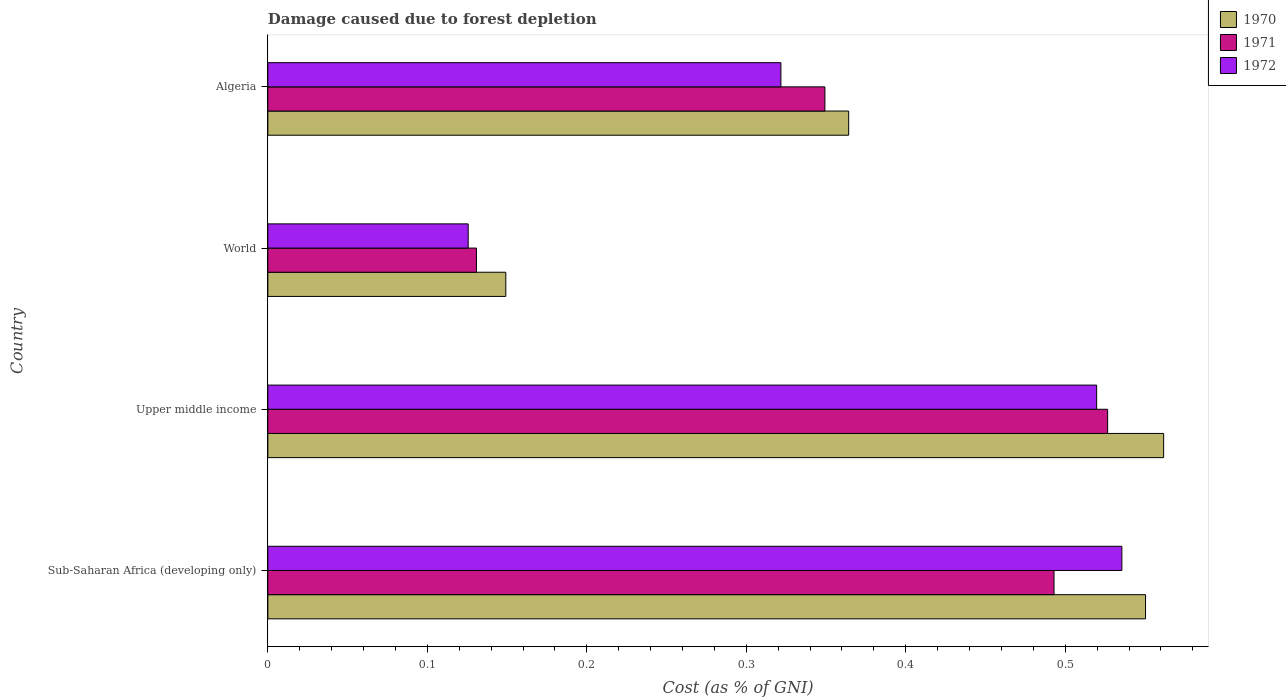How many different coloured bars are there?
Make the answer very short. 3. How many groups of bars are there?
Keep it short and to the point. 4. Are the number of bars per tick equal to the number of legend labels?
Make the answer very short. Yes. What is the label of the 4th group of bars from the top?
Offer a very short reply. Sub-Saharan Africa (developing only). In how many cases, is the number of bars for a given country not equal to the number of legend labels?
Provide a succinct answer. 0. What is the cost of damage caused due to forest depletion in 1971 in Upper middle income?
Keep it short and to the point. 0.53. Across all countries, what is the maximum cost of damage caused due to forest depletion in 1971?
Your answer should be very brief. 0.53. Across all countries, what is the minimum cost of damage caused due to forest depletion in 1970?
Ensure brevity in your answer.  0.15. In which country was the cost of damage caused due to forest depletion in 1970 maximum?
Keep it short and to the point. Upper middle income. In which country was the cost of damage caused due to forest depletion in 1972 minimum?
Your response must be concise. World. What is the total cost of damage caused due to forest depletion in 1970 in the graph?
Ensure brevity in your answer.  1.63. What is the difference between the cost of damage caused due to forest depletion in 1972 in Sub-Saharan Africa (developing only) and that in Upper middle income?
Provide a short and direct response. 0.02. What is the difference between the cost of damage caused due to forest depletion in 1970 in Sub-Saharan Africa (developing only) and the cost of damage caused due to forest depletion in 1971 in World?
Provide a succinct answer. 0.42. What is the average cost of damage caused due to forest depletion in 1972 per country?
Provide a succinct answer. 0.38. What is the difference between the cost of damage caused due to forest depletion in 1972 and cost of damage caused due to forest depletion in 1970 in Sub-Saharan Africa (developing only)?
Give a very brief answer. -0.01. What is the ratio of the cost of damage caused due to forest depletion in 1971 in Sub-Saharan Africa (developing only) to that in World?
Ensure brevity in your answer.  3.77. Is the difference between the cost of damage caused due to forest depletion in 1972 in Sub-Saharan Africa (developing only) and World greater than the difference between the cost of damage caused due to forest depletion in 1970 in Sub-Saharan Africa (developing only) and World?
Offer a very short reply. Yes. What is the difference between the highest and the second highest cost of damage caused due to forest depletion in 1972?
Give a very brief answer. 0.02. What is the difference between the highest and the lowest cost of damage caused due to forest depletion in 1971?
Your response must be concise. 0.4. In how many countries, is the cost of damage caused due to forest depletion in 1970 greater than the average cost of damage caused due to forest depletion in 1970 taken over all countries?
Make the answer very short. 2. Is the sum of the cost of damage caused due to forest depletion in 1971 in Upper middle income and World greater than the maximum cost of damage caused due to forest depletion in 1970 across all countries?
Offer a very short reply. Yes. What does the 2nd bar from the top in Upper middle income represents?
Make the answer very short. 1971. How many bars are there?
Provide a succinct answer. 12. What is the difference between two consecutive major ticks on the X-axis?
Provide a short and direct response. 0.1. Does the graph contain any zero values?
Offer a very short reply. No. Does the graph contain grids?
Keep it short and to the point. No. Where does the legend appear in the graph?
Your answer should be very brief. Top right. How many legend labels are there?
Your response must be concise. 3. What is the title of the graph?
Offer a terse response. Damage caused due to forest depletion. What is the label or title of the X-axis?
Give a very brief answer. Cost (as % of GNI). What is the Cost (as % of GNI) of 1970 in Sub-Saharan Africa (developing only)?
Offer a terse response. 0.55. What is the Cost (as % of GNI) of 1971 in Sub-Saharan Africa (developing only)?
Your answer should be very brief. 0.49. What is the Cost (as % of GNI) of 1972 in Sub-Saharan Africa (developing only)?
Your answer should be compact. 0.54. What is the Cost (as % of GNI) in 1970 in Upper middle income?
Give a very brief answer. 0.56. What is the Cost (as % of GNI) of 1971 in Upper middle income?
Your answer should be very brief. 0.53. What is the Cost (as % of GNI) in 1972 in Upper middle income?
Offer a very short reply. 0.52. What is the Cost (as % of GNI) of 1970 in World?
Your answer should be compact. 0.15. What is the Cost (as % of GNI) in 1971 in World?
Give a very brief answer. 0.13. What is the Cost (as % of GNI) in 1972 in World?
Provide a short and direct response. 0.13. What is the Cost (as % of GNI) in 1970 in Algeria?
Your response must be concise. 0.36. What is the Cost (as % of GNI) of 1971 in Algeria?
Your answer should be compact. 0.35. What is the Cost (as % of GNI) in 1972 in Algeria?
Ensure brevity in your answer.  0.32. Across all countries, what is the maximum Cost (as % of GNI) in 1970?
Ensure brevity in your answer.  0.56. Across all countries, what is the maximum Cost (as % of GNI) of 1971?
Your answer should be very brief. 0.53. Across all countries, what is the maximum Cost (as % of GNI) of 1972?
Give a very brief answer. 0.54. Across all countries, what is the minimum Cost (as % of GNI) in 1970?
Your answer should be compact. 0.15. Across all countries, what is the minimum Cost (as % of GNI) in 1971?
Provide a short and direct response. 0.13. Across all countries, what is the minimum Cost (as % of GNI) in 1972?
Your response must be concise. 0.13. What is the total Cost (as % of GNI) in 1970 in the graph?
Make the answer very short. 1.63. What is the total Cost (as % of GNI) in 1971 in the graph?
Provide a succinct answer. 1.5. What is the total Cost (as % of GNI) of 1972 in the graph?
Your answer should be very brief. 1.5. What is the difference between the Cost (as % of GNI) in 1970 in Sub-Saharan Africa (developing only) and that in Upper middle income?
Give a very brief answer. -0.01. What is the difference between the Cost (as % of GNI) in 1971 in Sub-Saharan Africa (developing only) and that in Upper middle income?
Offer a terse response. -0.03. What is the difference between the Cost (as % of GNI) in 1972 in Sub-Saharan Africa (developing only) and that in Upper middle income?
Provide a succinct answer. 0.02. What is the difference between the Cost (as % of GNI) in 1970 in Sub-Saharan Africa (developing only) and that in World?
Offer a very short reply. 0.4. What is the difference between the Cost (as % of GNI) in 1971 in Sub-Saharan Africa (developing only) and that in World?
Your answer should be compact. 0.36. What is the difference between the Cost (as % of GNI) of 1972 in Sub-Saharan Africa (developing only) and that in World?
Give a very brief answer. 0.41. What is the difference between the Cost (as % of GNI) of 1970 in Sub-Saharan Africa (developing only) and that in Algeria?
Keep it short and to the point. 0.19. What is the difference between the Cost (as % of GNI) in 1971 in Sub-Saharan Africa (developing only) and that in Algeria?
Provide a succinct answer. 0.14. What is the difference between the Cost (as % of GNI) in 1972 in Sub-Saharan Africa (developing only) and that in Algeria?
Give a very brief answer. 0.21. What is the difference between the Cost (as % of GNI) of 1970 in Upper middle income and that in World?
Make the answer very short. 0.41. What is the difference between the Cost (as % of GNI) in 1971 in Upper middle income and that in World?
Provide a short and direct response. 0.4. What is the difference between the Cost (as % of GNI) in 1972 in Upper middle income and that in World?
Your answer should be compact. 0.39. What is the difference between the Cost (as % of GNI) of 1970 in Upper middle income and that in Algeria?
Your answer should be very brief. 0.2. What is the difference between the Cost (as % of GNI) of 1971 in Upper middle income and that in Algeria?
Provide a succinct answer. 0.18. What is the difference between the Cost (as % of GNI) of 1972 in Upper middle income and that in Algeria?
Your answer should be very brief. 0.2. What is the difference between the Cost (as % of GNI) of 1970 in World and that in Algeria?
Keep it short and to the point. -0.21. What is the difference between the Cost (as % of GNI) in 1971 in World and that in Algeria?
Your answer should be compact. -0.22. What is the difference between the Cost (as % of GNI) of 1972 in World and that in Algeria?
Your answer should be very brief. -0.2. What is the difference between the Cost (as % of GNI) of 1970 in Sub-Saharan Africa (developing only) and the Cost (as % of GNI) of 1971 in Upper middle income?
Give a very brief answer. 0.02. What is the difference between the Cost (as % of GNI) in 1970 in Sub-Saharan Africa (developing only) and the Cost (as % of GNI) in 1972 in Upper middle income?
Give a very brief answer. 0.03. What is the difference between the Cost (as % of GNI) in 1971 in Sub-Saharan Africa (developing only) and the Cost (as % of GNI) in 1972 in Upper middle income?
Make the answer very short. -0.03. What is the difference between the Cost (as % of GNI) in 1970 in Sub-Saharan Africa (developing only) and the Cost (as % of GNI) in 1971 in World?
Make the answer very short. 0.42. What is the difference between the Cost (as % of GNI) in 1970 in Sub-Saharan Africa (developing only) and the Cost (as % of GNI) in 1972 in World?
Make the answer very short. 0.42. What is the difference between the Cost (as % of GNI) of 1971 in Sub-Saharan Africa (developing only) and the Cost (as % of GNI) of 1972 in World?
Provide a short and direct response. 0.37. What is the difference between the Cost (as % of GNI) in 1970 in Sub-Saharan Africa (developing only) and the Cost (as % of GNI) in 1971 in Algeria?
Offer a terse response. 0.2. What is the difference between the Cost (as % of GNI) in 1970 in Sub-Saharan Africa (developing only) and the Cost (as % of GNI) in 1972 in Algeria?
Offer a terse response. 0.23. What is the difference between the Cost (as % of GNI) of 1971 in Sub-Saharan Africa (developing only) and the Cost (as % of GNI) of 1972 in Algeria?
Provide a succinct answer. 0.17. What is the difference between the Cost (as % of GNI) in 1970 in Upper middle income and the Cost (as % of GNI) in 1971 in World?
Your answer should be compact. 0.43. What is the difference between the Cost (as % of GNI) of 1970 in Upper middle income and the Cost (as % of GNI) of 1972 in World?
Keep it short and to the point. 0.44. What is the difference between the Cost (as % of GNI) in 1971 in Upper middle income and the Cost (as % of GNI) in 1972 in World?
Your answer should be compact. 0.4. What is the difference between the Cost (as % of GNI) in 1970 in Upper middle income and the Cost (as % of GNI) in 1971 in Algeria?
Ensure brevity in your answer.  0.21. What is the difference between the Cost (as % of GNI) in 1970 in Upper middle income and the Cost (as % of GNI) in 1972 in Algeria?
Your response must be concise. 0.24. What is the difference between the Cost (as % of GNI) of 1971 in Upper middle income and the Cost (as % of GNI) of 1972 in Algeria?
Make the answer very short. 0.2. What is the difference between the Cost (as % of GNI) of 1970 in World and the Cost (as % of GNI) of 1971 in Algeria?
Your answer should be compact. -0.2. What is the difference between the Cost (as % of GNI) of 1970 in World and the Cost (as % of GNI) of 1972 in Algeria?
Your answer should be very brief. -0.17. What is the difference between the Cost (as % of GNI) in 1971 in World and the Cost (as % of GNI) in 1972 in Algeria?
Give a very brief answer. -0.19. What is the average Cost (as % of GNI) of 1970 per country?
Keep it short and to the point. 0.41. What is the average Cost (as % of GNI) in 1971 per country?
Ensure brevity in your answer.  0.37. What is the average Cost (as % of GNI) of 1972 per country?
Your answer should be very brief. 0.38. What is the difference between the Cost (as % of GNI) in 1970 and Cost (as % of GNI) in 1971 in Sub-Saharan Africa (developing only)?
Provide a succinct answer. 0.06. What is the difference between the Cost (as % of GNI) of 1970 and Cost (as % of GNI) of 1972 in Sub-Saharan Africa (developing only)?
Ensure brevity in your answer.  0.01. What is the difference between the Cost (as % of GNI) of 1971 and Cost (as % of GNI) of 1972 in Sub-Saharan Africa (developing only)?
Offer a terse response. -0.04. What is the difference between the Cost (as % of GNI) in 1970 and Cost (as % of GNI) in 1971 in Upper middle income?
Offer a very short reply. 0.04. What is the difference between the Cost (as % of GNI) in 1970 and Cost (as % of GNI) in 1972 in Upper middle income?
Offer a terse response. 0.04. What is the difference between the Cost (as % of GNI) in 1971 and Cost (as % of GNI) in 1972 in Upper middle income?
Provide a short and direct response. 0.01. What is the difference between the Cost (as % of GNI) in 1970 and Cost (as % of GNI) in 1971 in World?
Your response must be concise. 0.02. What is the difference between the Cost (as % of GNI) in 1970 and Cost (as % of GNI) in 1972 in World?
Give a very brief answer. 0.02. What is the difference between the Cost (as % of GNI) in 1971 and Cost (as % of GNI) in 1972 in World?
Your answer should be compact. 0.01. What is the difference between the Cost (as % of GNI) in 1970 and Cost (as % of GNI) in 1971 in Algeria?
Provide a short and direct response. 0.01. What is the difference between the Cost (as % of GNI) of 1970 and Cost (as % of GNI) of 1972 in Algeria?
Keep it short and to the point. 0.04. What is the difference between the Cost (as % of GNI) of 1971 and Cost (as % of GNI) of 1972 in Algeria?
Provide a short and direct response. 0.03. What is the ratio of the Cost (as % of GNI) of 1970 in Sub-Saharan Africa (developing only) to that in Upper middle income?
Offer a very short reply. 0.98. What is the ratio of the Cost (as % of GNI) of 1971 in Sub-Saharan Africa (developing only) to that in Upper middle income?
Give a very brief answer. 0.94. What is the ratio of the Cost (as % of GNI) in 1972 in Sub-Saharan Africa (developing only) to that in Upper middle income?
Your answer should be compact. 1.03. What is the ratio of the Cost (as % of GNI) of 1970 in Sub-Saharan Africa (developing only) to that in World?
Make the answer very short. 3.69. What is the ratio of the Cost (as % of GNI) in 1971 in Sub-Saharan Africa (developing only) to that in World?
Offer a terse response. 3.77. What is the ratio of the Cost (as % of GNI) in 1972 in Sub-Saharan Africa (developing only) to that in World?
Keep it short and to the point. 4.26. What is the ratio of the Cost (as % of GNI) of 1970 in Sub-Saharan Africa (developing only) to that in Algeria?
Offer a terse response. 1.51. What is the ratio of the Cost (as % of GNI) in 1971 in Sub-Saharan Africa (developing only) to that in Algeria?
Keep it short and to the point. 1.41. What is the ratio of the Cost (as % of GNI) in 1972 in Sub-Saharan Africa (developing only) to that in Algeria?
Ensure brevity in your answer.  1.66. What is the ratio of the Cost (as % of GNI) in 1970 in Upper middle income to that in World?
Offer a terse response. 3.76. What is the ratio of the Cost (as % of GNI) in 1971 in Upper middle income to that in World?
Make the answer very short. 4.03. What is the ratio of the Cost (as % of GNI) of 1972 in Upper middle income to that in World?
Make the answer very short. 4.14. What is the ratio of the Cost (as % of GNI) of 1970 in Upper middle income to that in Algeria?
Ensure brevity in your answer.  1.54. What is the ratio of the Cost (as % of GNI) of 1971 in Upper middle income to that in Algeria?
Your answer should be very brief. 1.51. What is the ratio of the Cost (as % of GNI) of 1972 in Upper middle income to that in Algeria?
Provide a short and direct response. 1.62. What is the ratio of the Cost (as % of GNI) in 1970 in World to that in Algeria?
Provide a succinct answer. 0.41. What is the ratio of the Cost (as % of GNI) of 1971 in World to that in Algeria?
Ensure brevity in your answer.  0.37. What is the ratio of the Cost (as % of GNI) of 1972 in World to that in Algeria?
Offer a very short reply. 0.39. What is the difference between the highest and the second highest Cost (as % of GNI) in 1970?
Offer a very short reply. 0.01. What is the difference between the highest and the second highest Cost (as % of GNI) of 1971?
Your response must be concise. 0.03. What is the difference between the highest and the second highest Cost (as % of GNI) of 1972?
Your answer should be compact. 0.02. What is the difference between the highest and the lowest Cost (as % of GNI) in 1970?
Offer a very short reply. 0.41. What is the difference between the highest and the lowest Cost (as % of GNI) in 1971?
Make the answer very short. 0.4. What is the difference between the highest and the lowest Cost (as % of GNI) of 1972?
Make the answer very short. 0.41. 